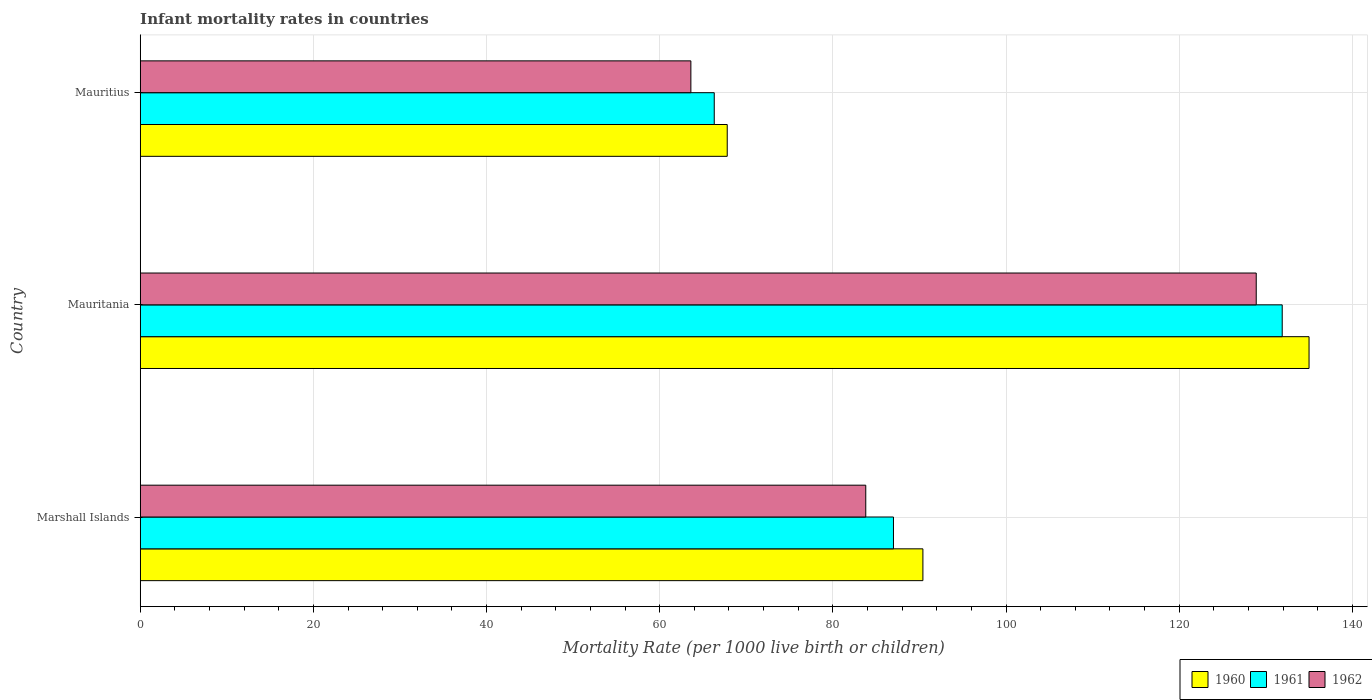Are the number of bars per tick equal to the number of legend labels?
Keep it short and to the point. Yes. How many bars are there on the 2nd tick from the top?
Your response must be concise. 3. What is the label of the 3rd group of bars from the top?
Keep it short and to the point. Marshall Islands. What is the infant mortality rate in 1962 in Mauritania?
Offer a very short reply. 128.9. Across all countries, what is the maximum infant mortality rate in 1962?
Your response must be concise. 128.9. Across all countries, what is the minimum infant mortality rate in 1961?
Offer a very short reply. 66.3. In which country was the infant mortality rate in 1962 maximum?
Your answer should be very brief. Mauritania. In which country was the infant mortality rate in 1960 minimum?
Your answer should be compact. Mauritius. What is the total infant mortality rate in 1962 in the graph?
Ensure brevity in your answer.  276.3. What is the difference between the infant mortality rate in 1961 in Marshall Islands and that in Mauritania?
Offer a very short reply. -44.9. What is the difference between the infant mortality rate in 1961 in Marshall Islands and the infant mortality rate in 1962 in Mauritania?
Give a very brief answer. -41.9. What is the average infant mortality rate in 1962 per country?
Make the answer very short. 92.1. What is the difference between the infant mortality rate in 1960 and infant mortality rate in 1961 in Marshall Islands?
Make the answer very short. 3.4. In how many countries, is the infant mortality rate in 1960 greater than 108 ?
Offer a terse response. 1. What is the ratio of the infant mortality rate in 1961 in Marshall Islands to that in Mauritius?
Keep it short and to the point. 1.31. Is the infant mortality rate in 1961 in Marshall Islands less than that in Mauritius?
Provide a short and direct response. No. What is the difference between the highest and the second highest infant mortality rate in 1960?
Your answer should be very brief. 44.6. What is the difference between the highest and the lowest infant mortality rate in 1961?
Keep it short and to the point. 65.6. In how many countries, is the infant mortality rate in 1962 greater than the average infant mortality rate in 1962 taken over all countries?
Your answer should be compact. 1. Is the sum of the infant mortality rate in 1961 in Marshall Islands and Mauritania greater than the maximum infant mortality rate in 1962 across all countries?
Give a very brief answer. Yes. What does the 3rd bar from the bottom in Marshall Islands represents?
Offer a terse response. 1962. How many bars are there?
Provide a succinct answer. 9. Are all the bars in the graph horizontal?
Provide a succinct answer. Yes. How many countries are there in the graph?
Your answer should be compact. 3. Does the graph contain grids?
Give a very brief answer. Yes. Where does the legend appear in the graph?
Your answer should be compact. Bottom right. How many legend labels are there?
Give a very brief answer. 3. How are the legend labels stacked?
Your answer should be very brief. Horizontal. What is the title of the graph?
Your answer should be very brief. Infant mortality rates in countries. Does "1982" appear as one of the legend labels in the graph?
Ensure brevity in your answer.  No. What is the label or title of the X-axis?
Your answer should be compact. Mortality Rate (per 1000 live birth or children). What is the Mortality Rate (per 1000 live birth or children) of 1960 in Marshall Islands?
Your answer should be very brief. 90.4. What is the Mortality Rate (per 1000 live birth or children) of 1961 in Marshall Islands?
Ensure brevity in your answer.  87. What is the Mortality Rate (per 1000 live birth or children) of 1962 in Marshall Islands?
Offer a terse response. 83.8. What is the Mortality Rate (per 1000 live birth or children) in 1960 in Mauritania?
Your answer should be compact. 135. What is the Mortality Rate (per 1000 live birth or children) in 1961 in Mauritania?
Your answer should be very brief. 131.9. What is the Mortality Rate (per 1000 live birth or children) of 1962 in Mauritania?
Make the answer very short. 128.9. What is the Mortality Rate (per 1000 live birth or children) in 1960 in Mauritius?
Offer a very short reply. 67.8. What is the Mortality Rate (per 1000 live birth or children) in 1961 in Mauritius?
Offer a very short reply. 66.3. What is the Mortality Rate (per 1000 live birth or children) in 1962 in Mauritius?
Your answer should be compact. 63.6. Across all countries, what is the maximum Mortality Rate (per 1000 live birth or children) of 1960?
Give a very brief answer. 135. Across all countries, what is the maximum Mortality Rate (per 1000 live birth or children) of 1961?
Give a very brief answer. 131.9. Across all countries, what is the maximum Mortality Rate (per 1000 live birth or children) of 1962?
Your answer should be compact. 128.9. Across all countries, what is the minimum Mortality Rate (per 1000 live birth or children) of 1960?
Make the answer very short. 67.8. Across all countries, what is the minimum Mortality Rate (per 1000 live birth or children) of 1961?
Make the answer very short. 66.3. Across all countries, what is the minimum Mortality Rate (per 1000 live birth or children) in 1962?
Your answer should be very brief. 63.6. What is the total Mortality Rate (per 1000 live birth or children) of 1960 in the graph?
Your response must be concise. 293.2. What is the total Mortality Rate (per 1000 live birth or children) in 1961 in the graph?
Offer a very short reply. 285.2. What is the total Mortality Rate (per 1000 live birth or children) of 1962 in the graph?
Your answer should be very brief. 276.3. What is the difference between the Mortality Rate (per 1000 live birth or children) in 1960 in Marshall Islands and that in Mauritania?
Ensure brevity in your answer.  -44.6. What is the difference between the Mortality Rate (per 1000 live birth or children) of 1961 in Marshall Islands and that in Mauritania?
Your answer should be compact. -44.9. What is the difference between the Mortality Rate (per 1000 live birth or children) of 1962 in Marshall Islands and that in Mauritania?
Keep it short and to the point. -45.1. What is the difference between the Mortality Rate (per 1000 live birth or children) of 1960 in Marshall Islands and that in Mauritius?
Keep it short and to the point. 22.6. What is the difference between the Mortality Rate (per 1000 live birth or children) of 1961 in Marshall Islands and that in Mauritius?
Your response must be concise. 20.7. What is the difference between the Mortality Rate (per 1000 live birth or children) in 1962 in Marshall Islands and that in Mauritius?
Ensure brevity in your answer.  20.2. What is the difference between the Mortality Rate (per 1000 live birth or children) in 1960 in Mauritania and that in Mauritius?
Offer a terse response. 67.2. What is the difference between the Mortality Rate (per 1000 live birth or children) in 1961 in Mauritania and that in Mauritius?
Ensure brevity in your answer.  65.6. What is the difference between the Mortality Rate (per 1000 live birth or children) of 1962 in Mauritania and that in Mauritius?
Keep it short and to the point. 65.3. What is the difference between the Mortality Rate (per 1000 live birth or children) of 1960 in Marshall Islands and the Mortality Rate (per 1000 live birth or children) of 1961 in Mauritania?
Your response must be concise. -41.5. What is the difference between the Mortality Rate (per 1000 live birth or children) in 1960 in Marshall Islands and the Mortality Rate (per 1000 live birth or children) in 1962 in Mauritania?
Make the answer very short. -38.5. What is the difference between the Mortality Rate (per 1000 live birth or children) in 1961 in Marshall Islands and the Mortality Rate (per 1000 live birth or children) in 1962 in Mauritania?
Ensure brevity in your answer.  -41.9. What is the difference between the Mortality Rate (per 1000 live birth or children) of 1960 in Marshall Islands and the Mortality Rate (per 1000 live birth or children) of 1961 in Mauritius?
Provide a short and direct response. 24.1. What is the difference between the Mortality Rate (per 1000 live birth or children) of 1960 in Marshall Islands and the Mortality Rate (per 1000 live birth or children) of 1962 in Mauritius?
Ensure brevity in your answer.  26.8. What is the difference between the Mortality Rate (per 1000 live birth or children) of 1961 in Marshall Islands and the Mortality Rate (per 1000 live birth or children) of 1962 in Mauritius?
Provide a succinct answer. 23.4. What is the difference between the Mortality Rate (per 1000 live birth or children) in 1960 in Mauritania and the Mortality Rate (per 1000 live birth or children) in 1961 in Mauritius?
Your answer should be very brief. 68.7. What is the difference between the Mortality Rate (per 1000 live birth or children) of 1960 in Mauritania and the Mortality Rate (per 1000 live birth or children) of 1962 in Mauritius?
Provide a succinct answer. 71.4. What is the difference between the Mortality Rate (per 1000 live birth or children) of 1961 in Mauritania and the Mortality Rate (per 1000 live birth or children) of 1962 in Mauritius?
Give a very brief answer. 68.3. What is the average Mortality Rate (per 1000 live birth or children) of 1960 per country?
Keep it short and to the point. 97.73. What is the average Mortality Rate (per 1000 live birth or children) in 1961 per country?
Provide a succinct answer. 95.07. What is the average Mortality Rate (per 1000 live birth or children) in 1962 per country?
Your response must be concise. 92.1. What is the difference between the Mortality Rate (per 1000 live birth or children) in 1960 and Mortality Rate (per 1000 live birth or children) in 1961 in Marshall Islands?
Your answer should be compact. 3.4. What is the difference between the Mortality Rate (per 1000 live birth or children) of 1960 and Mortality Rate (per 1000 live birth or children) of 1962 in Marshall Islands?
Provide a short and direct response. 6.6. What is the difference between the Mortality Rate (per 1000 live birth or children) in 1961 and Mortality Rate (per 1000 live birth or children) in 1962 in Mauritania?
Your response must be concise. 3. What is the difference between the Mortality Rate (per 1000 live birth or children) in 1960 and Mortality Rate (per 1000 live birth or children) in 1961 in Mauritius?
Offer a very short reply. 1.5. What is the difference between the Mortality Rate (per 1000 live birth or children) of 1961 and Mortality Rate (per 1000 live birth or children) of 1962 in Mauritius?
Provide a short and direct response. 2.7. What is the ratio of the Mortality Rate (per 1000 live birth or children) in 1960 in Marshall Islands to that in Mauritania?
Offer a terse response. 0.67. What is the ratio of the Mortality Rate (per 1000 live birth or children) in 1961 in Marshall Islands to that in Mauritania?
Offer a terse response. 0.66. What is the ratio of the Mortality Rate (per 1000 live birth or children) in 1962 in Marshall Islands to that in Mauritania?
Make the answer very short. 0.65. What is the ratio of the Mortality Rate (per 1000 live birth or children) in 1960 in Marshall Islands to that in Mauritius?
Ensure brevity in your answer.  1.33. What is the ratio of the Mortality Rate (per 1000 live birth or children) of 1961 in Marshall Islands to that in Mauritius?
Give a very brief answer. 1.31. What is the ratio of the Mortality Rate (per 1000 live birth or children) of 1962 in Marshall Islands to that in Mauritius?
Make the answer very short. 1.32. What is the ratio of the Mortality Rate (per 1000 live birth or children) in 1960 in Mauritania to that in Mauritius?
Your response must be concise. 1.99. What is the ratio of the Mortality Rate (per 1000 live birth or children) of 1961 in Mauritania to that in Mauritius?
Your answer should be very brief. 1.99. What is the ratio of the Mortality Rate (per 1000 live birth or children) of 1962 in Mauritania to that in Mauritius?
Your answer should be very brief. 2.03. What is the difference between the highest and the second highest Mortality Rate (per 1000 live birth or children) of 1960?
Keep it short and to the point. 44.6. What is the difference between the highest and the second highest Mortality Rate (per 1000 live birth or children) in 1961?
Your answer should be very brief. 44.9. What is the difference between the highest and the second highest Mortality Rate (per 1000 live birth or children) of 1962?
Provide a succinct answer. 45.1. What is the difference between the highest and the lowest Mortality Rate (per 1000 live birth or children) of 1960?
Keep it short and to the point. 67.2. What is the difference between the highest and the lowest Mortality Rate (per 1000 live birth or children) in 1961?
Your answer should be compact. 65.6. What is the difference between the highest and the lowest Mortality Rate (per 1000 live birth or children) of 1962?
Keep it short and to the point. 65.3. 